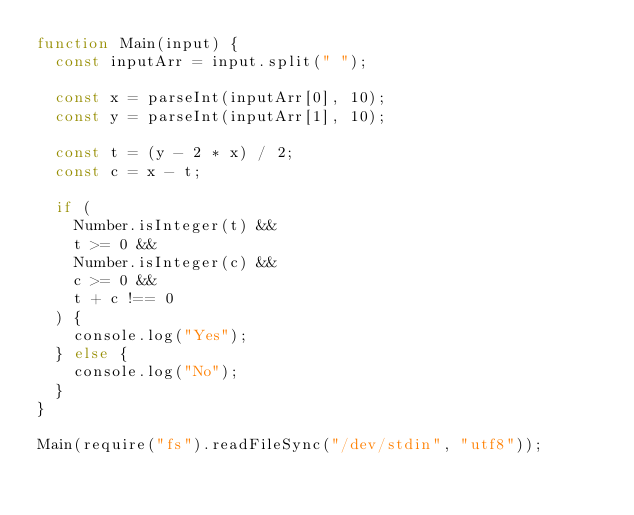Convert code to text. <code><loc_0><loc_0><loc_500><loc_500><_JavaScript_>function Main(input) {
  const inputArr = input.split(" ");

  const x = parseInt(inputArr[0], 10);
  const y = parseInt(inputArr[1], 10);

  const t = (y - 2 * x) / 2;
  const c = x - t;

  if (
    Number.isInteger(t) &&
    t >= 0 &&
    Number.isInteger(c) &&
    c >= 0 &&
    t + c !== 0
  ) {
    console.log("Yes");
  } else {
    console.log("No");
  }
}

Main(require("fs").readFileSync("/dev/stdin", "utf8"));
</code> 